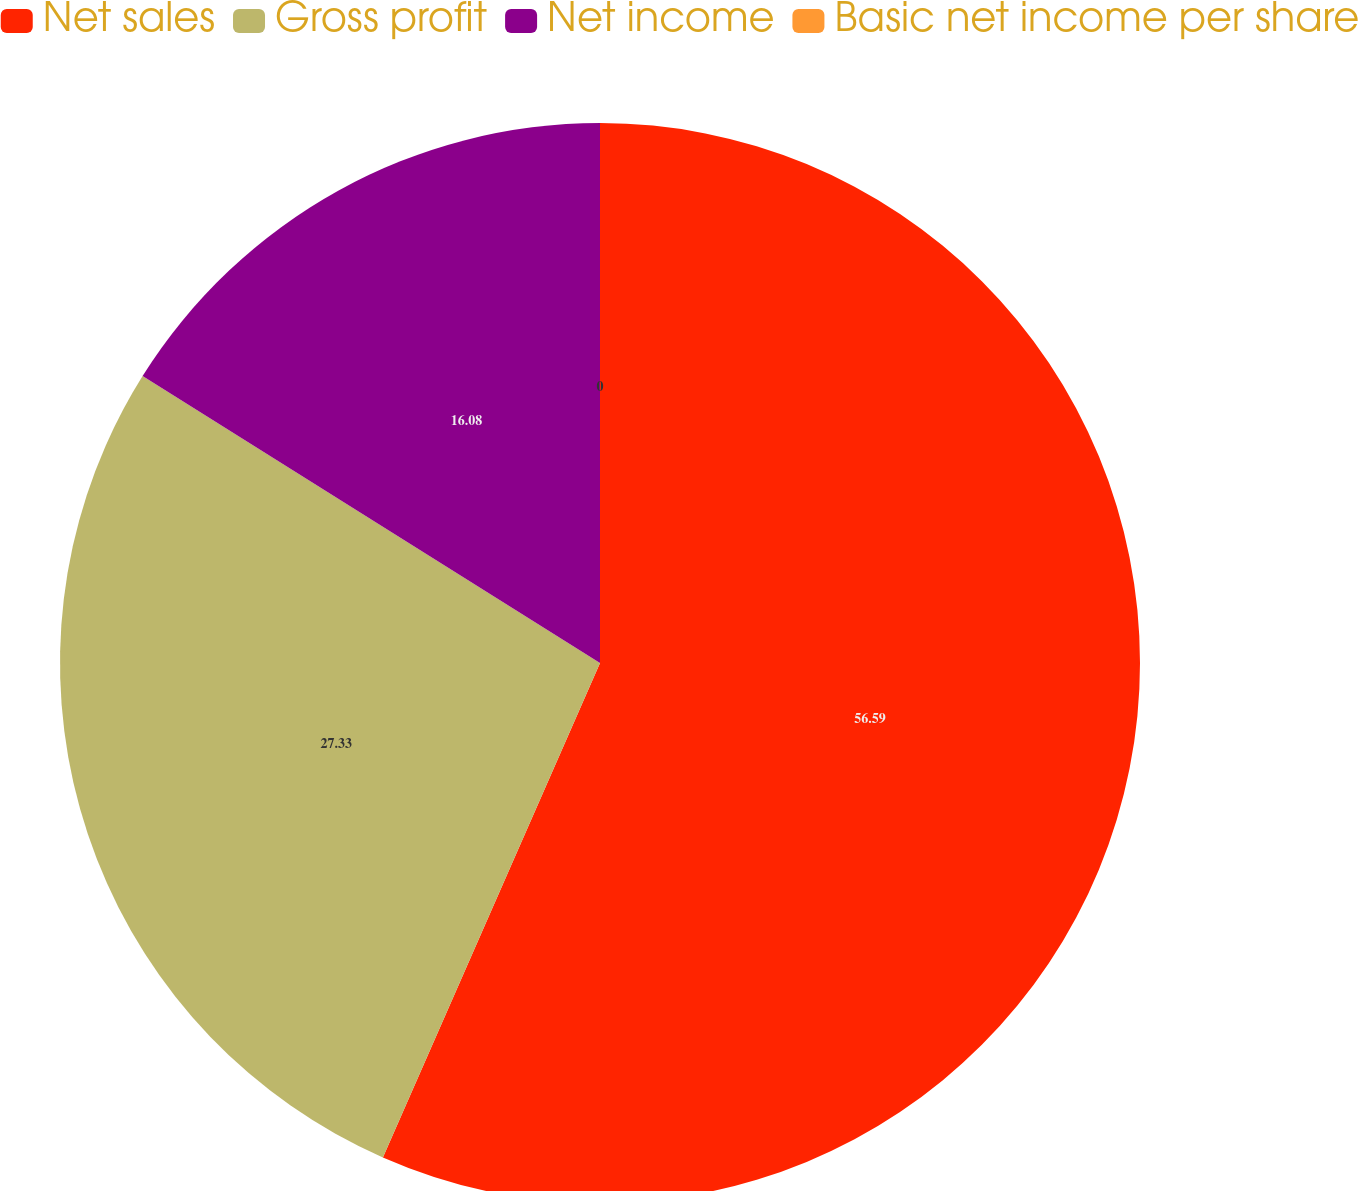<chart> <loc_0><loc_0><loc_500><loc_500><pie_chart><fcel>Net sales<fcel>Gross profit<fcel>Net income<fcel>Basic net income per share<nl><fcel>56.58%<fcel>27.33%<fcel>16.08%<fcel>0.0%<nl></chart> 